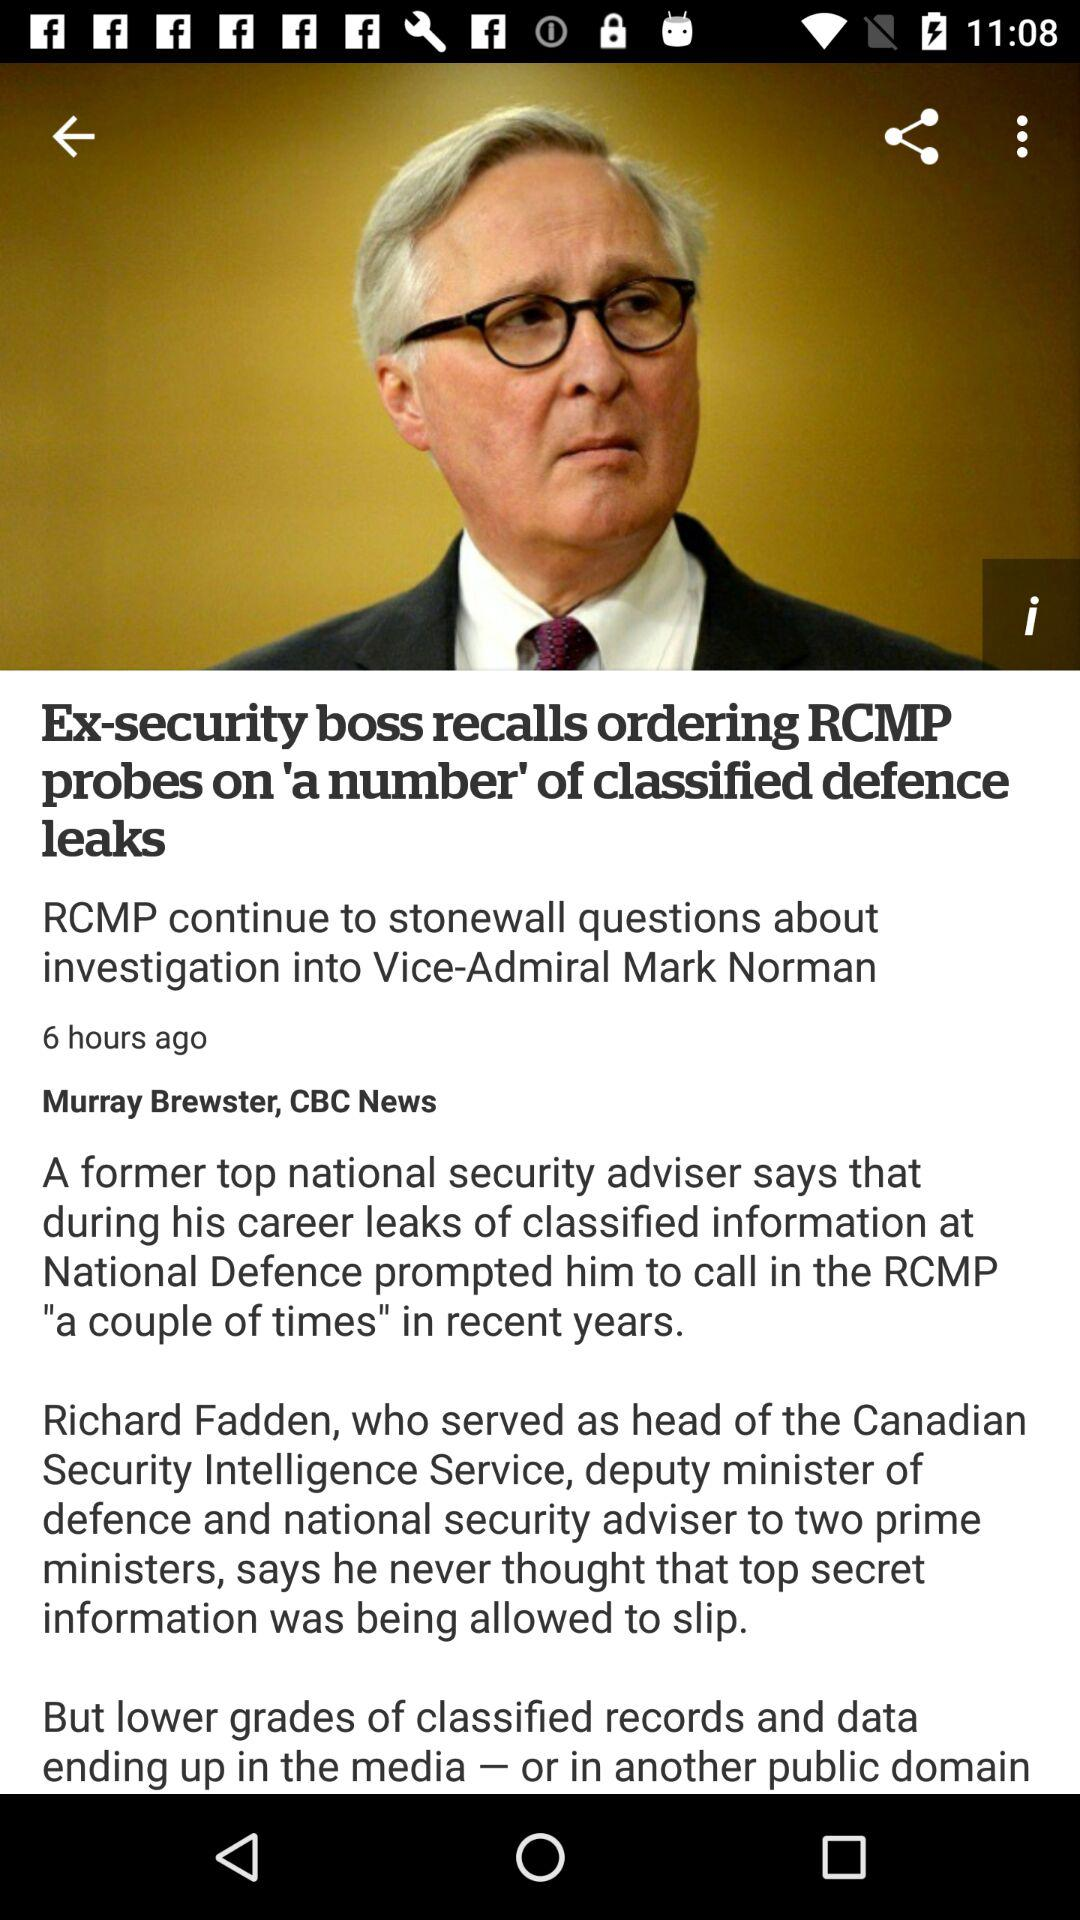How many hours ago was the article posted? The article was posted 6 hours ago. 